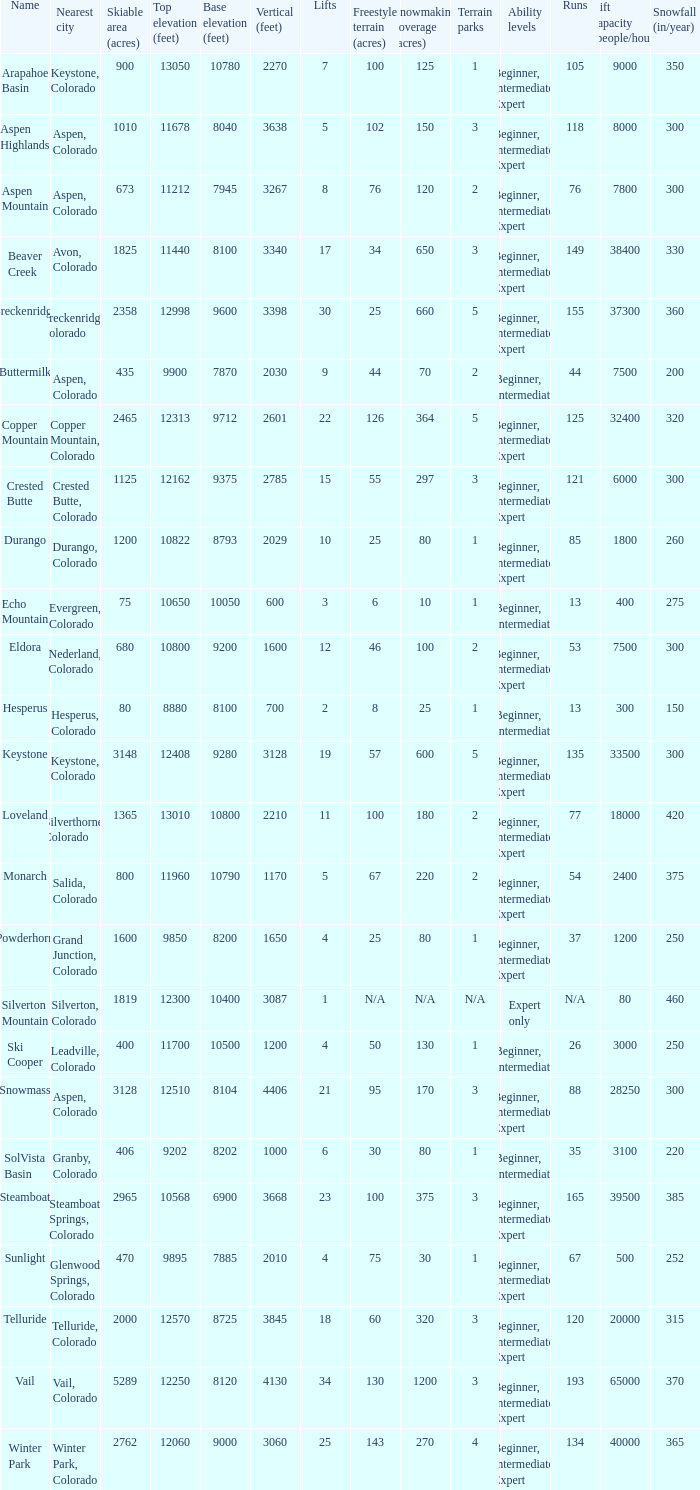How many resorts have 118 runs? 1.0. 